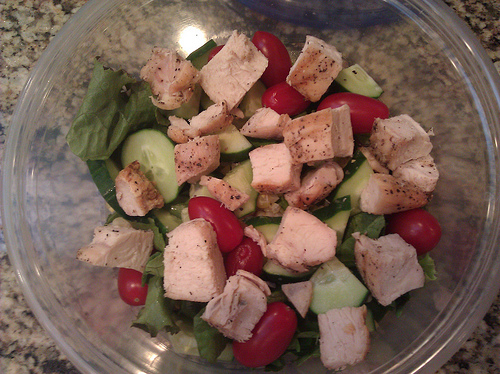<image>
Is there a food in the bowl? Yes. The food is contained within or inside the bowl, showing a containment relationship. 